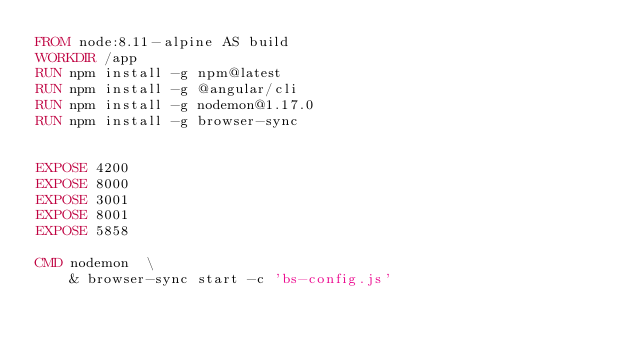Convert code to text. <code><loc_0><loc_0><loc_500><loc_500><_Dockerfile_>FROM node:8.11-alpine AS build
WORKDIR /app
RUN npm install -g npm@latest
RUN npm install -g @angular/cli
RUN npm install -g nodemon@1.17.0
RUN npm install -g browser-sync


EXPOSE 4200
EXPOSE 8000
EXPOSE 3001
EXPOSE 8001
EXPOSE 5858

CMD nodemon  \
    & browser-sync start -c 'bs-config.js'
</code> 